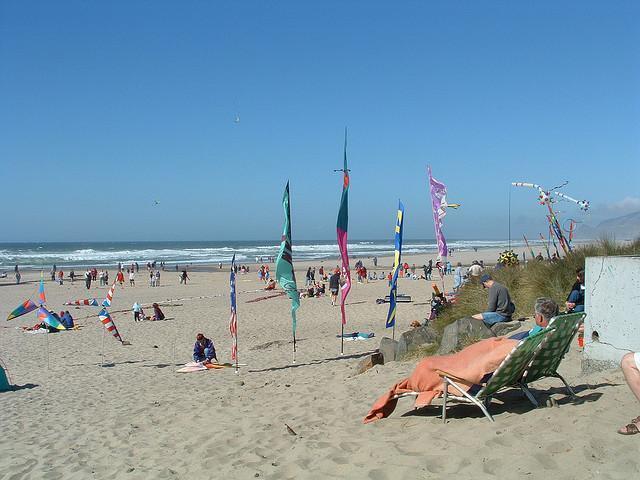How many chairs can be seen?
Give a very brief answer. 2. How many zebras are there?
Give a very brief answer. 0. 